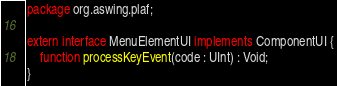<code> <loc_0><loc_0><loc_500><loc_500><_Haxe_>package org.aswing.plaf;

extern interface MenuElementUI implements ComponentUI {
	function processKeyEvent(code : UInt) : Void;
}
</code> 